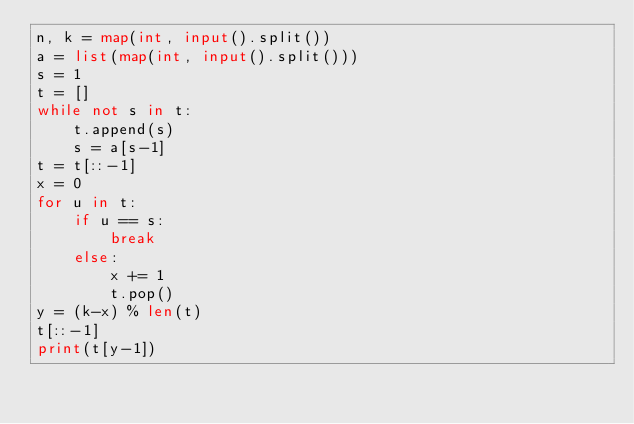Convert code to text. <code><loc_0><loc_0><loc_500><loc_500><_Python_>n, k = map(int, input().split())
a = list(map(int, input().split()))
s = 1
t = []
while not s in t:
    t.append(s)
    s = a[s-1]
t = t[::-1]
x = 0
for u in t:
    if u == s:
        break
    else:
        x += 1
        t.pop()
y = (k-x) % len(t)
t[::-1]
print(t[y-1])
        </code> 